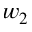Convert formula to latex. <formula><loc_0><loc_0><loc_500><loc_500>w _ { 2 }</formula> 